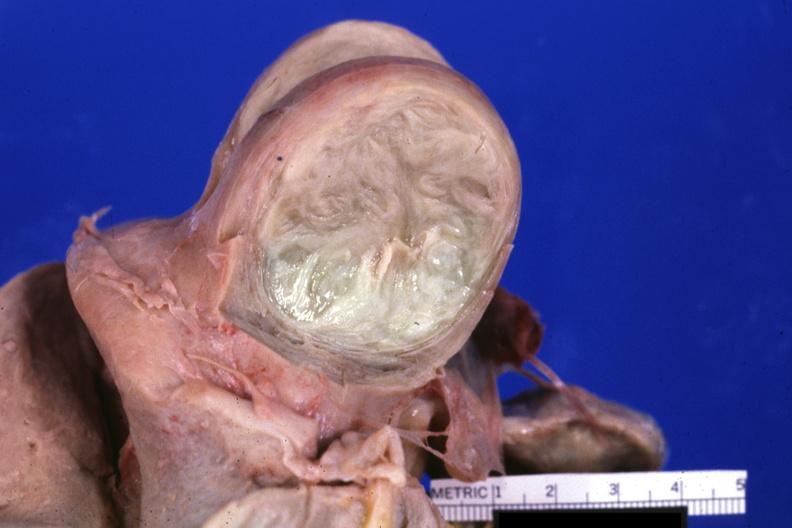s conjoined twins present?
Answer the question using a single word or phrase. No 